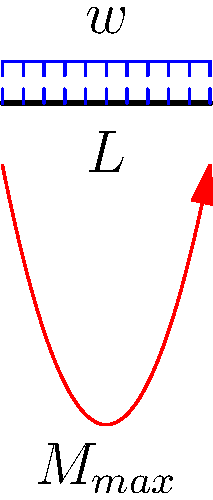Dans le diagramme du moment fléchissant d'une poutre simplement appuyée avec une charge uniformément répartie $w$, quelle est l'expression poétique du moment fléchissant maximal $M_{max}$ en fonction de $w$ et de la longueur de la poutre $L$ ? Imaginez ce moment comme le point culminant d'un arc photographique capturant l'essence de la mécanique des structures. Pour trouver le moment fléchissant maximal, suivons ces étapes poétiques :

1) La charge distribuée crée une symphonie de forces le long de la poutre.

2) Le moment fléchissant à une distance $x$ de l'appui gauche s'exprime par :
   $$M(x) = \frac{wx}{2}(L-x)$$

3) Cette expression forme une parabole, comme un arc gracieux dans le ciel de la mécanique.

4) Le sommet de cet arc, notre moment maximal, se trouve au centre de la poutre, où $x = \frac{L}{2}$.

5) En substituant dans notre équation poétique :
   $$M_{max} = M(\frac{L}{2}) = \frac{w\frac{L}{2}}{2}(L-\frac{L}{2}) = \frac{wL^2}{8}$$

6) Ainsi, le moment maximal se révèle, capturant l'essence de la charge et de la longueur dans une seule expression élégante.
Answer: $M_{max} = \frac{wL^2}{8}$ 